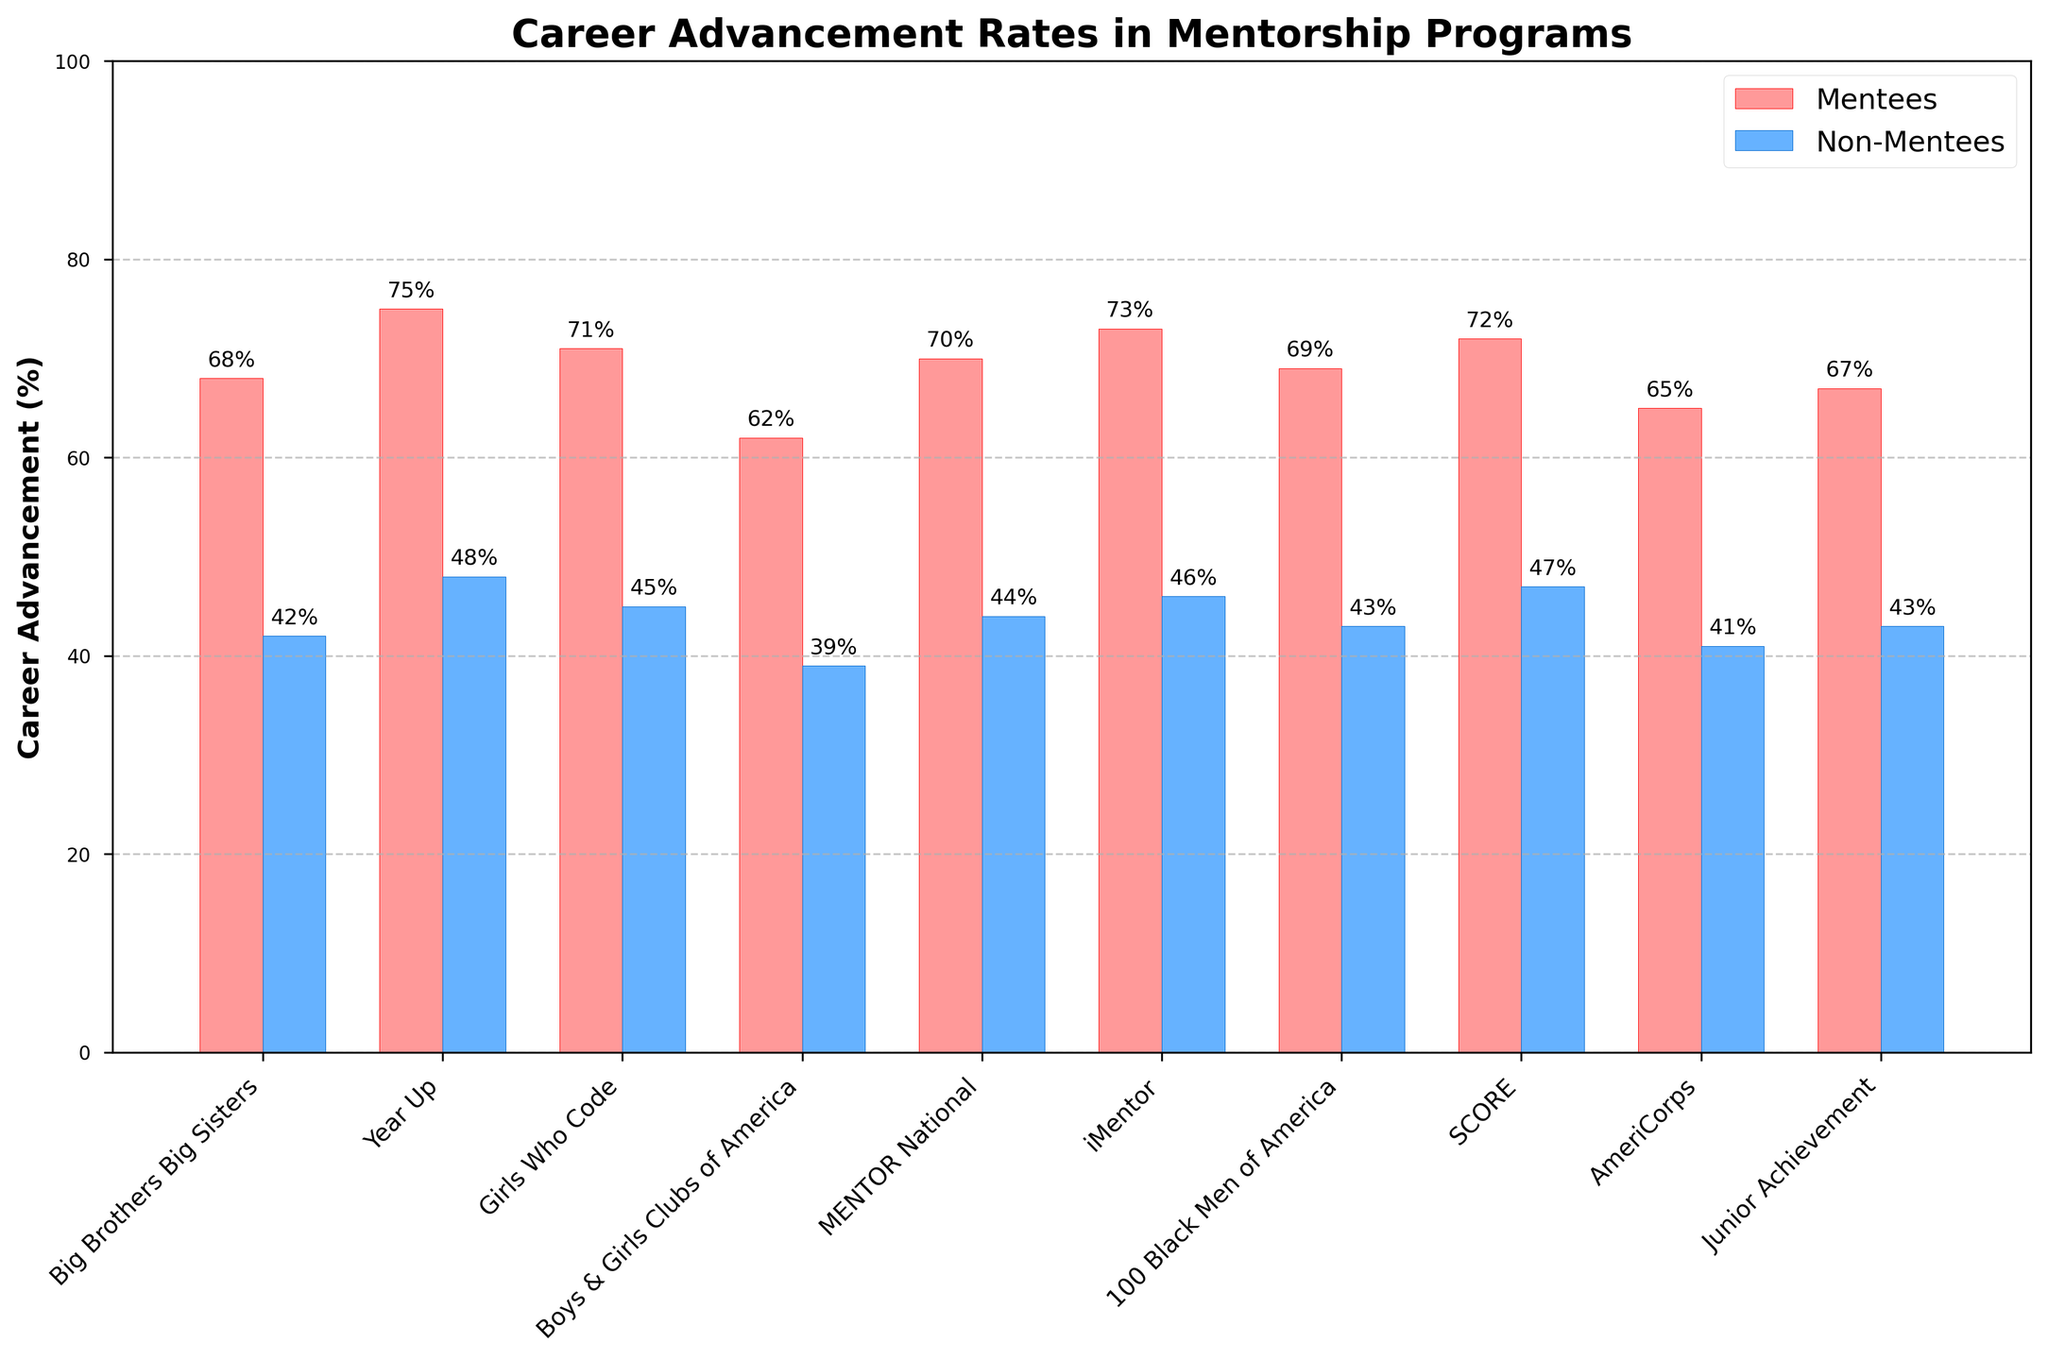Which program has the highest career advancement rate for mentees? Look at the heights of the bars representing mentees for each program. Identify the tallest bar.
Answer: Year Up What's the difference in career advancement rates between mentees and non-mentees in the Girls Who Code program? Identify the values for mentees and non-mentees in the Girls Who Code program from the bars and calculate the difference. Mentees have 71% and non-mentees have 45%. The difference is 71 - 45.
Answer: 26% Which program has the smallest differential in career advancement rates between mentees and non-mentees? Compute the difference between the mentee and non-mentee bars for each program. Find the program with the smallest difference. The differentials are: Big Brothers Big Sisters (26), Year Up (27), Girls Who Code (26), Boys & Girls Clubs of America (23), MENTOR National (26), iMentor (27), 100 Black Men of America (26), SCORE (25), AmeriCorps (24), Junior Achievement (24). The smallest difference is for Boys & Girls Clubs of America (23).
Answer: Boys & Girls Clubs of America Which mentorship program shows the largest increase in career advancement rates when comparing mentees to non-mentees? Calculate the difference in advancement rates for each program by subtracting non-mentee values from mentee values. Identify the largest difference. Year Up shows the largest difference: 75% - 48% = 27%.
Answer: Year Up How does the career advancement rate for mentees in the iMentor program compare to that of the SCORE program? Check the heights of the bars for the mentees in both iMentor and SCORE programs and compare their values. iMentor is at 73% and SCORE is at 72%.
Answer: iMentor is higher What is the average career advancement rate for mentees across all programs? Add up the advancement rates for mentees from all programs and divide by the number of programs. (68 + 75 + 71 + 62 + 70 + 73 + 69 + 72 + 65 + 67) / 10 = 69.2
Answer: 69.2% Which programs have a career advancement rate of over 70% for mentees? Look at the heights of the bars for mentees and identify those at or above 70%. The bars for Year Up (75%), Girls Who Code (71%), MENTOR National (70%), iMentor (73%), and SCORE (72%) meet this criterion.
Answer: Year Up, Girls Who Code, MENTOR National, iMentor, SCORE Can you compare the career advancement rates for mentees and non-mentees in the Junior Achievement program? Identify the percentage values for both mentees and non-mentees in the Junior Achievement program. Mentees have a rate of 67% and non-mentees have 43%. Mentees have a 24% higher rate than non-mentees.
Answer: Mentees are 24% higher What is the median career advancement rate for non-mentees across all programs? List the rates for non-mentees: 42, 48, 45, 39, 44, 46, 43, 47, 41, 43. Arrange them in ascending order: 39, 41, 42, 43, 43, 44, 45, 46, 47, 48. The median value is the average of the 5th and 6th data points. (43 + 44) / 2 = 43.5
Answer: 43.5% Which program has the lowest career advancement rate among non-mentees? Look at the heights of the bars representing non-mentees for each program. Identify the shortest bar. Boys & Girls Clubs of America have the lowest rate at 39%.
Answer: Boys & Girls Clubs of America 